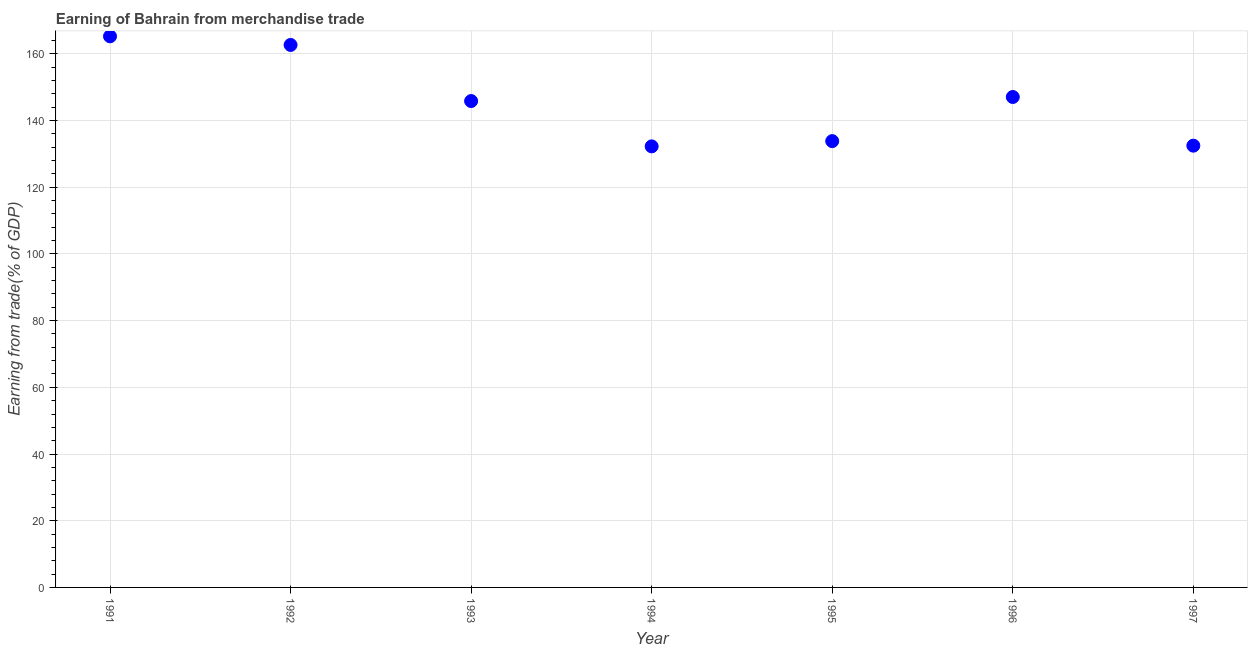What is the earning from merchandise trade in 1997?
Make the answer very short. 132.46. Across all years, what is the maximum earning from merchandise trade?
Offer a very short reply. 165.24. Across all years, what is the minimum earning from merchandise trade?
Provide a succinct answer. 132.25. What is the sum of the earning from merchandise trade?
Ensure brevity in your answer.  1019.32. What is the difference between the earning from merchandise trade in 1991 and 1997?
Ensure brevity in your answer.  32.79. What is the average earning from merchandise trade per year?
Ensure brevity in your answer.  145.62. What is the median earning from merchandise trade?
Ensure brevity in your answer.  145.84. Do a majority of the years between 1991 and 1995 (inclusive) have earning from merchandise trade greater than 12 %?
Your response must be concise. Yes. What is the ratio of the earning from merchandise trade in 1993 to that in 1996?
Provide a succinct answer. 0.99. Is the earning from merchandise trade in 1991 less than that in 1994?
Offer a very short reply. No. What is the difference between the highest and the second highest earning from merchandise trade?
Provide a succinct answer. 2.58. What is the difference between the highest and the lowest earning from merchandise trade?
Provide a succinct answer. 32.99. What is the difference between two consecutive major ticks on the Y-axis?
Make the answer very short. 20. Does the graph contain any zero values?
Provide a succinct answer. No. Does the graph contain grids?
Ensure brevity in your answer.  Yes. What is the title of the graph?
Offer a terse response. Earning of Bahrain from merchandise trade. What is the label or title of the X-axis?
Provide a succinct answer. Year. What is the label or title of the Y-axis?
Give a very brief answer. Earning from trade(% of GDP). What is the Earning from trade(% of GDP) in 1991?
Your answer should be very brief. 165.24. What is the Earning from trade(% of GDP) in 1992?
Your response must be concise. 162.66. What is the Earning from trade(% of GDP) in 1993?
Your answer should be compact. 145.84. What is the Earning from trade(% of GDP) in 1994?
Keep it short and to the point. 132.25. What is the Earning from trade(% of GDP) in 1995?
Offer a very short reply. 133.82. What is the Earning from trade(% of GDP) in 1996?
Your answer should be compact. 147.05. What is the Earning from trade(% of GDP) in 1997?
Your response must be concise. 132.46. What is the difference between the Earning from trade(% of GDP) in 1991 and 1992?
Offer a very short reply. 2.58. What is the difference between the Earning from trade(% of GDP) in 1991 and 1993?
Make the answer very short. 19.4. What is the difference between the Earning from trade(% of GDP) in 1991 and 1994?
Give a very brief answer. 32.99. What is the difference between the Earning from trade(% of GDP) in 1991 and 1995?
Offer a very short reply. 31.42. What is the difference between the Earning from trade(% of GDP) in 1991 and 1996?
Make the answer very short. 18.19. What is the difference between the Earning from trade(% of GDP) in 1991 and 1997?
Provide a succinct answer. 32.79. What is the difference between the Earning from trade(% of GDP) in 1992 and 1993?
Offer a terse response. 16.82. What is the difference between the Earning from trade(% of GDP) in 1992 and 1994?
Make the answer very short. 30.41. What is the difference between the Earning from trade(% of GDP) in 1992 and 1995?
Make the answer very short. 28.83. What is the difference between the Earning from trade(% of GDP) in 1992 and 1996?
Your response must be concise. 15.6. What is the difference between the Earning from trade(% of GDP) in 1992 and 1997?
Make the answer very short. 30.2. What is the difference between the Earning from trade(% of GDP) in 1993 and 1994?
Ensure brevity in your answer.  13.59. What is the difference between the Earning from trade(% of GDP) in 1993 and 1995?
Make the answer very short. 12.01. What is the difference between the Earning from trade(% of GDP) in 1993 and 1996?
Provide a short and direct response. -1.21. What is the difference between the Earning from trade(% of GDP) in 1993 and 1997?
Provide a succinct answer. 13.38. What is the difference between the Earning from trade(% of GDP) in 1994 and 1995?
Your response must be concise. -1.58. What is the difference between the Earning from trade(% of GDP) in 1994 and 1996?
Provide a short and direct response. -14.81. What is the difference between the Earning from trade(% of GDP) in 1994 and 1997?
Make the answer very short. -0.21. What is the difference between the Earning from trade(% of GDP) in 1995 and 1996?
Ensure brevity in your answer.  -13.23. What is the difference between the Earning from trade(% of GDP) in 1995 and 1997?
Your answer should be compact. 1.37. What is the difference between the Earning from trade(% of GDP) in 1996 and 1997?
Provide a short and direct response. 14.6. What is the ratio of the Earning from trade(% of GDP) in 1991 to that in 1993?
Offer a terse response. 1.13. What is the ratio of the Earning from trade(% of GDP) in 1991 to that in 1994?
Provide a succinct answer. 1.25. What is the ratio of the Earning from trade(% of GDP) in 1991 to that in 1995?
Keep it short and to the point. 1.24. What is the ratio of the Earning from trade(% of GDP) in 1991 to that in 1996?
Keep it short and to the point. 1.12. What is the ratio of the Earning from trade(% of GDP) in 1991 to that in 1997?
Provide a short and direct response. 1.25. What is the ratio of the Earning from trade(% of GDP) in 1992 to that in 1993?
Ensure brevity in your answer.  1.11. What is the ratio of the Earning from trade(% of GDP) in 1992 to that in 1994?
Provide a succinct answer. 1.23. What is the ratio of the Earning from trade(% of GDP) in 1992 to that in 1995?
Give a very brief answer. 1.22. What is the ratio of the Earning from trade(% of GDP) in 1992 to that in 1996?
Offer a very short reply. 1.11. What is the ratio of the Earning from trade(% of GDP) in 1992 to that in 1997?
Your answer should be very brief. 1.23. What is the ratio of the Earning from trade(% of GDP) in 1993 to that in 1994?
Offer a very short reply. 1.1. What is the ratio of the Earning from trade(% of GDP) in 1993 to that in 1995?
Your response must be concise. 1.09. What is the ratio of the Earning from trade(% of GDP) in 1993 to that in 1997?
Offer a very short reply. 1.1. What is the ratio of the Earning from trade(% of GDP) in 1994 to that in 1996?
Keep it short and to the point. 0.9. What is the ratio of the Earning from trade(% of GDP) in 1995 to that in 1996?
Provide a succinct answer. 0.91. What is the ratio of the Earning from trade(% of GDP) in 1995 to that in 1997?
Make the answer very short. 1.01. What is the ratio of the Earning from trade(% of GDP) in 1996 to that in 1997?
Keep it short and to the point. 1.11. 